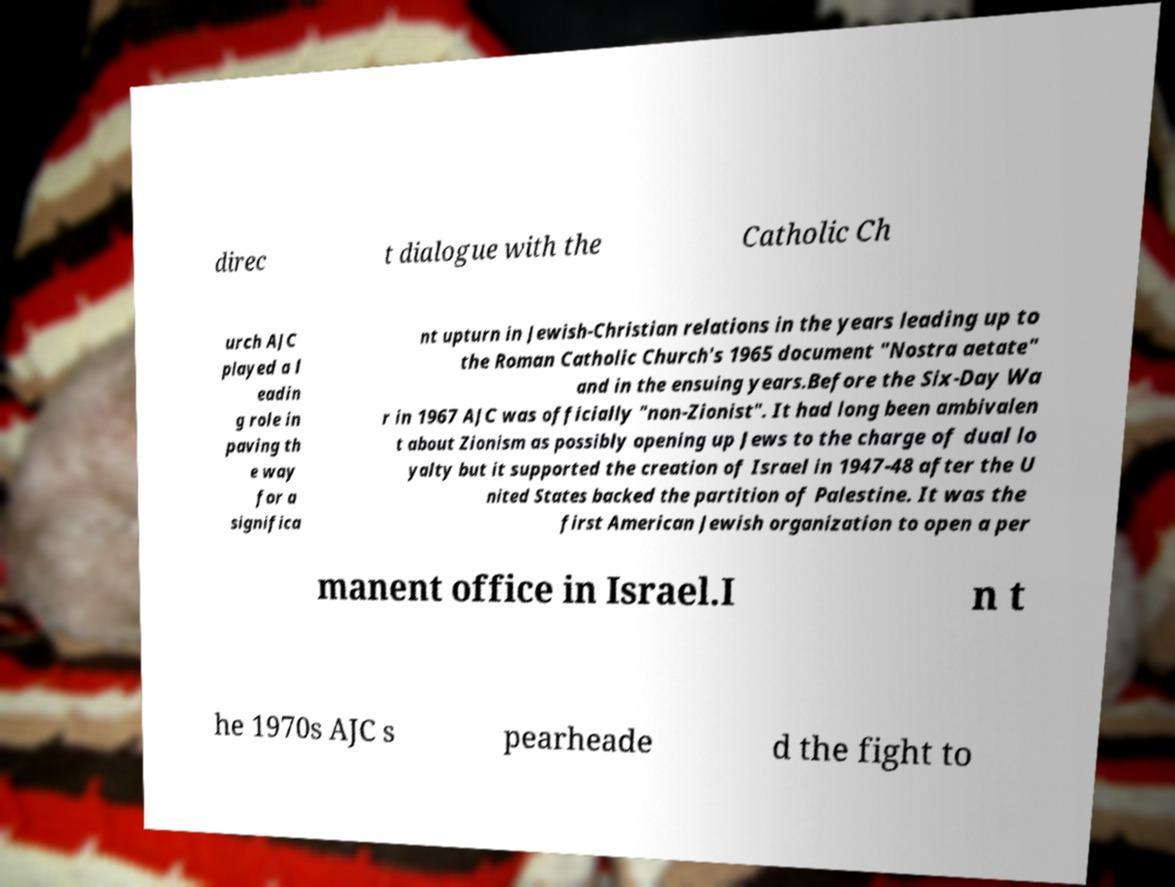Please identify and transcribe the text found in this image. direc t dialogue with the Catholic Ch urch AJC played a l eadin g role in paving th e way for a significa nt upturn in Jewish-Christian relations in the years leading up to the Roman Catholic Church's 1965 document "Nostra aetate" and in the ensuing years.Before the Six-Day Wa r in 1967 AJC was officially "non-Zionist". It had long been ambivalen t about Zionism as possibly opening up Jews to the charge of dual lo yalty but it supported the creation of Israel in 1947-48 after the U nited States backed the partition of Palestine. It was the first American Jewish organization to open a per manent office in Israel.I n t he 1970s AJC s pearheade d the fight to 